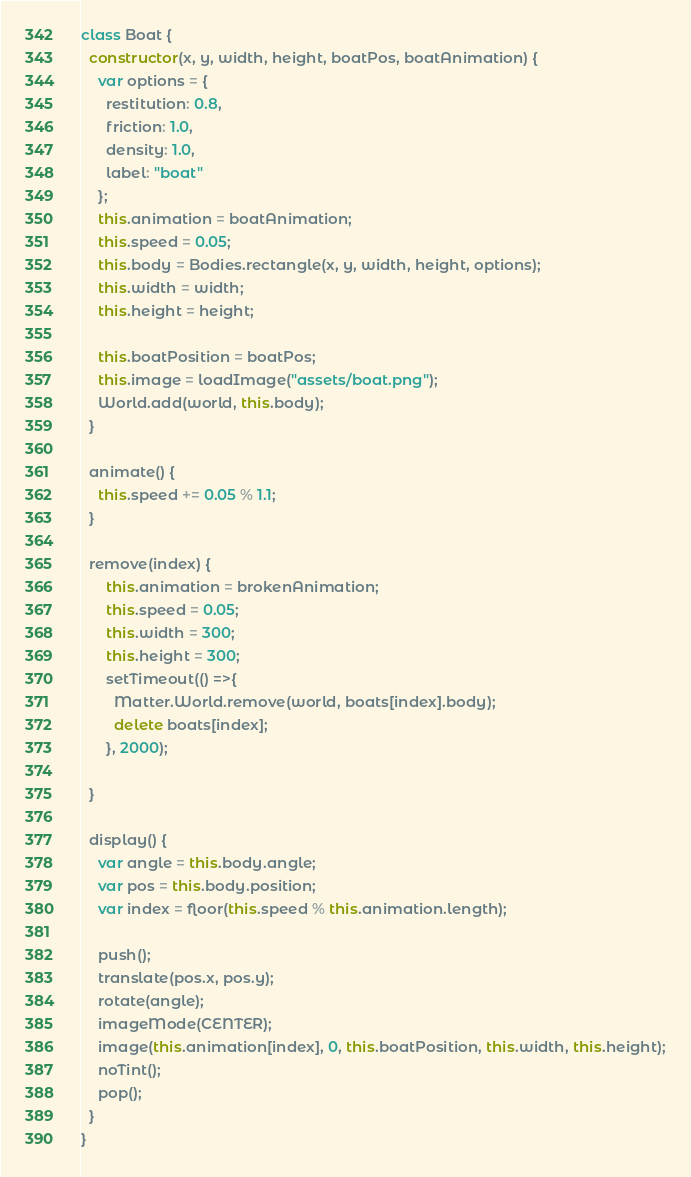<code> <loc_0><loc_0><loc_500><loc_500><_JavaScript_>class Boat {
  constructor(x, y, width, height, boatPos, boatAnimation) {
    var options = {
      restitution: 0.8,
      friction: 1.0,
      density: 1.0,
      label: "boat"
    };
    this.animation = boatAnimation;
    this.speed = 0.05;
    this.body = Bodies.rectangle(x, y, width, height, options);
    this.width = width;
    this.height = height;

    this.boatPosition = boatPos;
    this.image = loadImage("assets/boat.png");
    World.add(world, this.body);
  }

  animate() {
    this.speed += 0.05 % 1.1;
  }

  remove(index) {
      this.animation = brokenAnimation;
      this.speed = 0.05;
      this.width = 300;
      this.height = 300;
      setTimeout(() =>{
        Matter.World.remove(world, boats[index].body);
        delete boats[index];
      }, 2000);
    
  }

  display() {
    var angle = this.body.angle;
    var pos = this.body.position;
    var index = floor(this.speed % this.animation.length);
    
    push();
    translate(pos.x, pos.y);
    rotate(angle);
    imageMode(CENTER);
    image(this.animation[index], 0, this.boatPosition, this.width, this.height);
    noTint();
    pop();
  }
}
</code> 